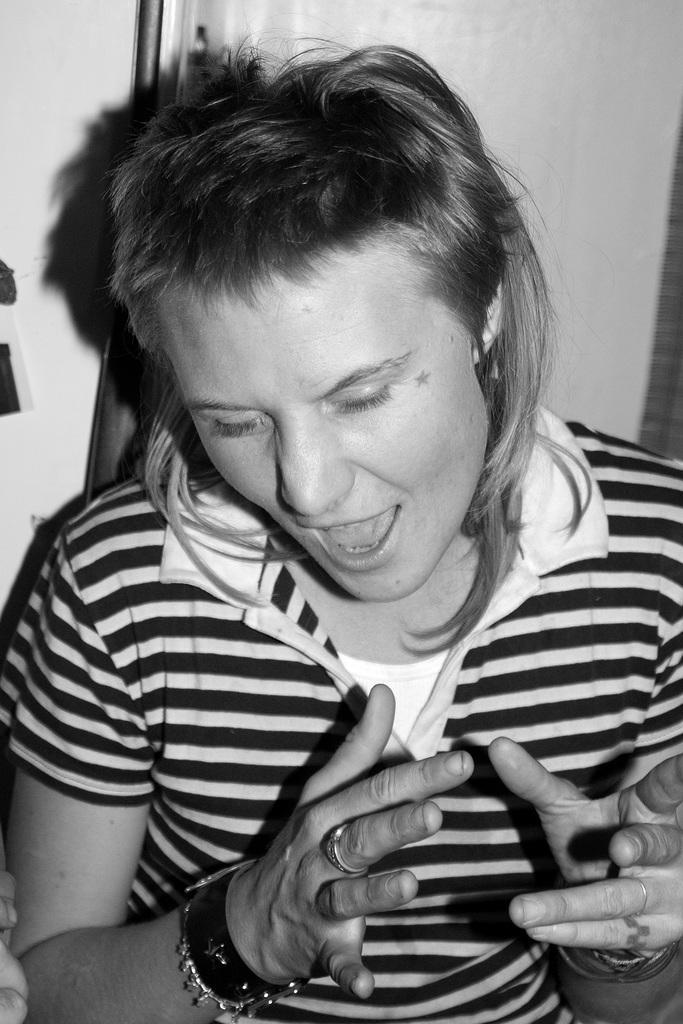In one or two sentences, can you explain what this image depicts? This is a zoomed in picture. In the foreground there is a person wearing t-shirt and seems to be standing. In the background there is wall and some other objects. 